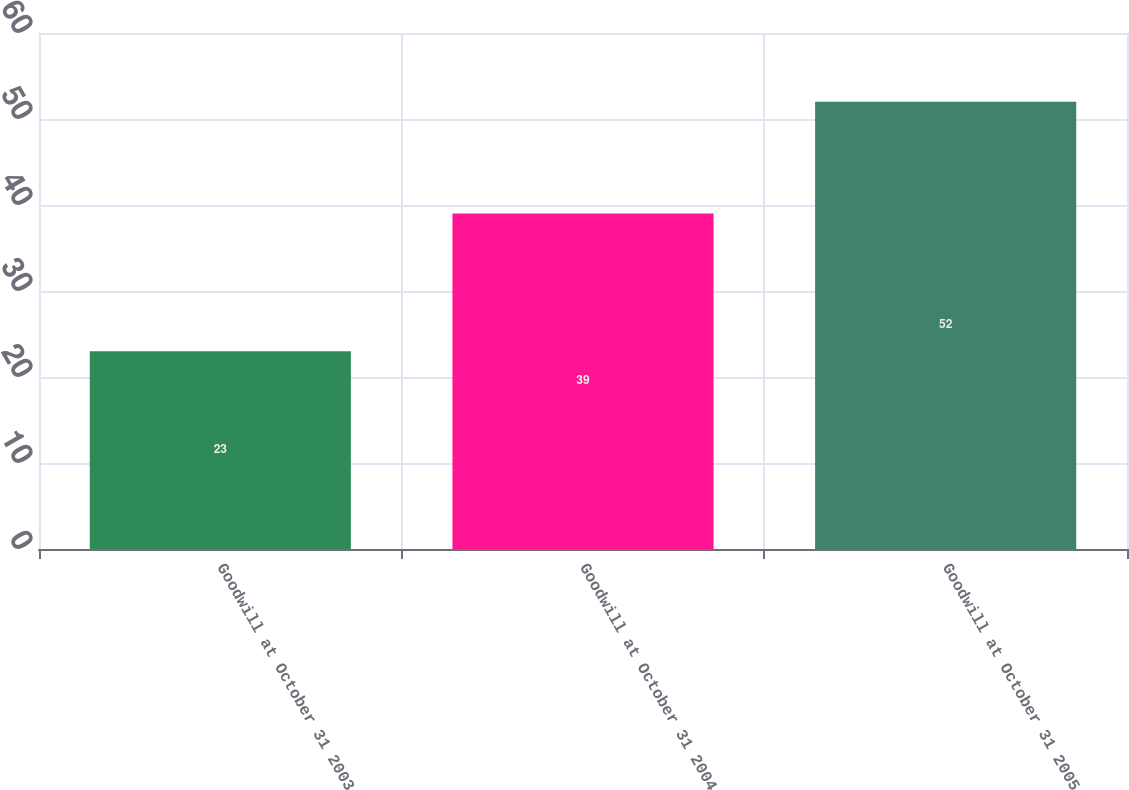Convert chart. <chart><loc_0><loc_0><loc_500><loc_500><bar_chart><fcel>Goodwill at October 31 2003<fcel>Goodwill at October 31 2004<fcel>Goodwill at October 31 2005<nl><fcel>23<fcel>39<fcel>52<nl></chart> 